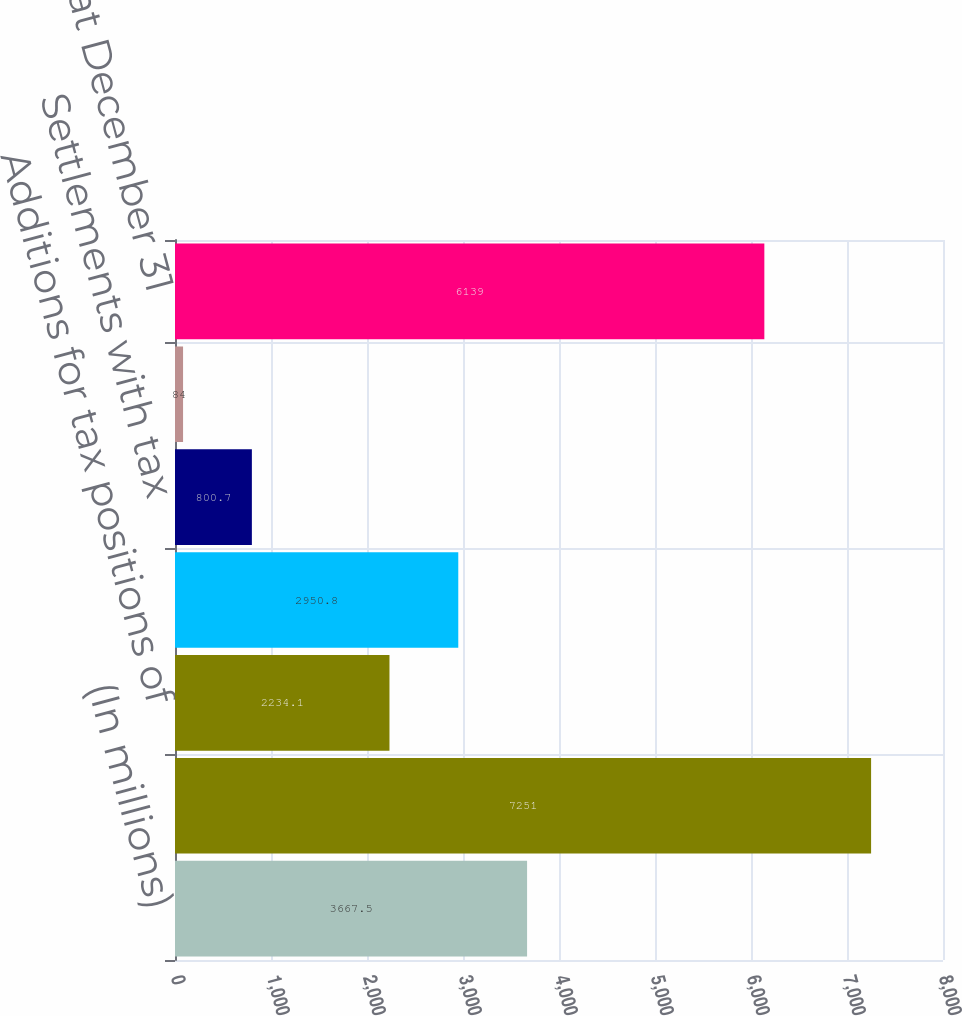<chart> <loc_0><loc_0><loc_500><loc_500><bar_chart><fcel>(In millions)<fcel>Balance at January 1<fcel>Additions for tax positions of<fcel>Reductions for tax positions<fcel>Settlements with tax<fcel>Expiration of the statute of<fcel>Balance at December 31<nl><fcel>3667.5<fcel>7251<fcel>2234.1<fcel>2950.8<fcel>800.7<fcel>84<fcel>6139<nl></chart> 